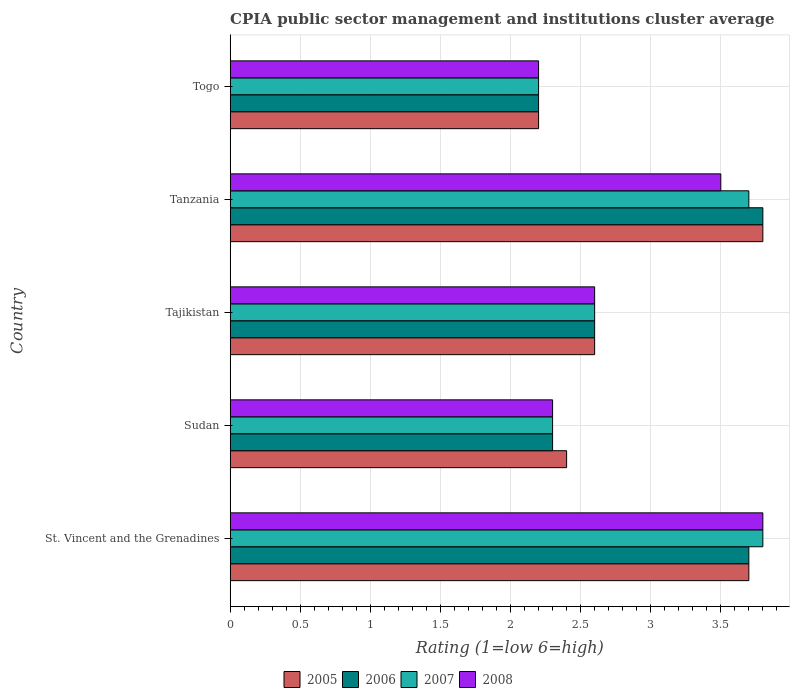How many groups of bars are there?
Offer a very short reply. 5. Are the number of bars on each tick of the Y-axis equal?
Ensure brevity in your answer.  Yes. How many bars are there on the 3rd tick from the top?
Offer a very short reply. 4. How many bars are there on the 4th tick from the bottom?
Offer a very short reply. 4. What is the label of the 2nd group of bars from the top?
Give a very brief answer. Tanzania. In how many cases, is the number of bars for a given country not equal to the number of legend labels?
Offer a very short reply. 0. Across all countries, what is the maximum CPIA rating in 2005?
Your response must be concise. 3.8. In which country was the CPIA rating in 2005 maximum?
Your answer should be very brief. Tanzania. In which country was the CPIA rating in 2008 minimum?
Ensure brevity in your answer.  Togo. What is the total CPIA rating in 2005 in the graph?
Offer a very short reply. 14.7. What is the difference between the CPIA rating in 2008 in St. Vincent and the Grenadines and that in Tanzania?
Your answer should be compact. 0.3. What is the difference between the CPIA rating in 2008 in Togo and the CPIA rating in 2006 in Tanzania?
Your answer should be very brief. -1.6. What is the average CPIA rating in 2006 per country?
Make the answer very short. 2.92. What is the difference between the CPIA rating in 2008 and CPIA rating in 2007 in St. Vincent and the Grenadines?
Your answer should be compact. 0. What is the ratio of the CPIA rating in 2008 in Sudan to that in Tajikistan?
Offer a terse response. 0.88. Is the CPIA rating in 2005 in Sudan less than that in Tajikistan?
Your response must be concise. Yes. Is the difference between the CPIA rating in 2008 in Tanzania and Togo greater than the difference between the CPIA rating in 2007 in Tanzania and Togo?
Your answer should be very brief. No. What is the difference between the highest and the second highest CPIA rating in 2006?
Your answer should be very brief. 0.1. What is the difference between the highest and the lowest CPIA rating in 2007?
Offer a terse response. 1.6. Is it the case that in every country, the sum of the CPIA rating in 2006 and CPIA rating in 2005 is greater than the sum of CPIA rating in 2007 and CPIA rating in 2008?
Your answer should be very brief. No. What does the 4th bar from the top in Sudan represents?
Your response must be concise. 2005. What does the 2nd bar from the bottom in Sudan represents?
Give a very brief answer. 2006. Is it the case that in every country, the sum of the CPIA rating in 2007 and CPIA rating in 2008 is greater than the CPIA rating in 2005?
Ensure brevity in your answer.  Yes. How many bars are there?
Ensure brevity in your answer.  20. Are all the bars in the graph horizontal?
Ensure brevity in your answer.  Yes. What is the difference between two consecutive major ticks on the X-axis?
Provide a short and direct response. 0.5. Are the values on the major ticks of X-axis written in scientific E-notation?
Keep it short and to the point. No. Does the graph contain any zero values?
Your response must be concise. No. Where does the legend appear in the graph?
Keep it short and to the point. Bottom center. How are the legend labels stacked?
Your answer should be very brief. Horizontal. What is the title of the graph?
Ensure brevity in your answer.  CPIA public sector management and institutions cluster average. What is the Rating (1=low 6=high) in 2005 in St. Vincent and the Grenadines?
Make the answer very short. 3.7. What is the Rating (1=low 6=high) in 2006 in St. Vincent and the Grenadines?
Ensure brevity in your answer.  3.7. What is the Rating (1=low 6=high) of 2008 in Sudan?
Your answer should be very brief. 2.3. What is the Rating (1=low 6=high) of 2006 in Tajikistan?
Offer a very short reply. 2.6. What is the Rating (1=low 6=high) of 2007 in Tajikistan?
Provide a succinct answer. 2.6. What is the Rating (1=low 6=high) in 2008 in Tajikistan?
Provide a succinct answer. 2.6. What is the Rating (1=low 6=high) in 2005 in Tanzania?
Give a very brief answer. 3.8. What is the Rating (1=low 6=high) of 2006 in Tanzania?
Your answer should be compact. 3.8. What is the Rating (1=low 6=high) in 2007 in Tanzania?
Your answer should be compact. 3.7. What is the Rating (1=low 6=high) of 2005 in Togo?
Make the answer very short. 2.2. What is the Rating (1=low 6=high) in 2008 in Togo?
Your answer should be compact. 2.2. Across all countries, what is the maximum Rating (1=low 6=high) in 2005?
Ensure brevity in your answer.  3.8. Across all countries, what is the maximum Rating (1=low 6=high) in 2008?
Ensure brevity in your answer.  3.8. Across all countries, what is the minimum Rating (1=low 6=high) in 2005?
Offer a very short reply. 2.2. Across all countries, what is the minimum Rating (1=low 6=high) in 2008?
Provide a short and direct response. 2.2. What is the total Rating (1=low 6=high) in 2006 in the graph?
Your answer should be compact. 14.6. What is the total Rating (1=low 6=high) of 2008 in the graph?
Keep it short and to the point. 14.4. What is the difference between the Rating (1=low 6=high) of 2006 in St. Vincent and the Grenadines and that in Sudan?
Provide a short and direct response. 1.4. What is the difference between the Rating (1=low 6=high) in 2005 in St. Vincent and the Grenadines and that in Tajikistan?
Provide a short and direct response. 1.1. What is the difference between the Rating (1=low 6=high) in 2007 in St. Vincent and the Grenadines and that in Tajikistan?
Provide a short and direct response. 1.2. What is the difference between the Rating (1=low 6=high) in 2008 in St. Vincent and the Grenadines and that in Tajikistan?
Offer a very short reply. 1.2. What is the difference between the Rating (1=low 6=high) of 2005 in St. Vincent and the Grenadines and that in Tanzania?
Your answer should be compact. -0.1. What is the difference between the Rating (1=low 6=high) of 2006 in St. Vincent and the Grenadines and that in Tanzania?
Offer a terse response. -0.1. What is the difference between the Rating (1=low 6=high) in 2007 in St. Vincent and the Grenadines and that in Tanzania?
Keep it short and to the point. 0.1. What is the difference between the Rating (1=low 6=high) in 2006 in St. Vincent and the Grenadines and that in Togo?
Ensure brevity in your answer.  1.5. What is the difference between the Rating (1=low 6=high) in 2006 in Sudan and that in Tajikistan?
Offer a very short reply. -0.3. What is the difference between the Rating (1=low 6=high) in 2007 in Sudan and that in Tajikistan?
Offer a very short reply. -0.3. What is the difference between the Rating (1=low 6=high) in 2008 in Sudan and that in Tajikistan?
Provide a short and direct response. -0.3. What is the difference between the Rating (1=low 6=high) in 2006 in Sudan and that in Tanzania?
Provide a succinct answer. -1.5. What is the difference between the Rating (1=low 6=high) in 2008 in Sudan and that in Tanzania?
Offer a very short reply. -1.2. What is the difference between the Rating (1=low 6=high) in 2006 in Sudan and that in Togo?
Ensure brevity in your answer.  0.1. What is the difference between the Rating (1=low 6=high) in 2007 in Sudan and that in Togo?
Give a very brief answer. 0.1. What is the difference between the Rating (1=low 6=high) in 2008 in Sudan and that in Togo?
Offer a very short reply. 0.1. What is the difference between the Rating (1=low 6=high) in 2008 in Tajikistan and that in Togo?
Keep it short and to the point. 0.4. What is the difference between the Rating (1=low 6=high) of 2007 in Tanzania and that in Togo?
Keep it short and to the point. 1.5. What is the difference between the Rating (1=low 6=high) of 2008 in Tanzania and that in Togo?
Offer a very short reply. 1.3. What is the difference between the Rating (1=low 6=high) of 2005 in St. Vincent and the Grenadines and the Rating (1=low 6=high) of 2007 in Sudan?
Offer a terse response. 1.4. What is the difference between the Rating (1=low 6=high) in 2005 in St. Vincent and the Grenadines and the Rating (1=low 6=high) in 2008 in Sudan?
Your answer should be very brief. 1.4. What is the difference between the Rating (1=low 6=high) in 2005 in St. Vincent and the Grenadines and the Rating (1=low 6=high) in 2006 in Tajikistan?
Keep it short and to the point. 1.1. What is the difference between the Rating (1=low 6=high) of 2006 in St. Vincent and the Grenadines and the Rating (1=low 6=high) of 2007 in Tajikistan?
Offer a terse response. 1.1. What is the difference between the Rating (1=low 6=high) of 2007 in St. Vincent and the Grenadines and the Rating (1=low 6=high) of 2008 in Tajikistan?
Offer a terse response. 1.2. What is the difference between the Rating (1=low 6=high) of 2005 in St. Vincent and the Grenadines and the Rating (1=low 6=high) of 2006 in Tanzania?
Your answer should be very brief. -0.1. What is the difference between the Rating (1=low 6=high) in 2005 in St. Vincent and the Grenadines and the Rating (1=low 6=high) in 2008 in Tanzania?
Offer a terse response. 0.2. What is the difference between the Rating (1=low 6=high) of 2006 in St. Vincent and the Grenadines and the Rating (1=low 6=high) of 2007 in Tanzania?
Your answer should be compact. 0. What is the difference between the Rating (1=low 6=high) in 2006 in St. Vincent and the Grenadines and the Rating (1=low 6=high) in 2008 in Tanzania?
Offer a terse response. 0.2. What is the difference between the Rating (1=low 6=high) in 2006 in St. Vincent and the Grenadines and the Rating (1=low 6=high) in 2008 in Togo?
Provide a short and direct response. 1.5. What is the difference between the Rating (1=low 6=high) of 2007 in St. Vincent and the Grenadines and the Rating (1=low 6=high) of 2008 in Togo?
Offer a terse response. 1.6. What is the difference between the Rating (1=low 6=high) of 2005 in Sudan and the Rating (1=low 6=high) of 2007 in Tajikistan?
Your answer should be very brief. -0.2. What is the difference between the Rating (1=low 6=high) in 2006 in Sudan and the Rating (1=low 6=high) in 2008 in Tajikistan?
Give a very brief answer. -0.3. What is the difference between the Rating (1=low 6=high) in 2007 in Sudan and the Rating (1=low 6=high) in 2008 in Tajikistan?
Provide a short and direct response. -0.3. What is the difference between the Rating (1=low 6=high) in 2006 in Sudan and the Rating (1=low 6=high) in 2007 in Tanzania?
Offer a very short reply. -1.4. What is the difference between the Rating (1=low 6=high) in 2007 in Sudan and the Rating (1=low 6=high) in 2008 in Tanzania?
Provide a succinct answer. -1.2. What is the difference between the Rating (1=low 6=high) in 2005 in Sudan and the Rating (1=low 6=high) in 2007 in Togo?
Provide a short and direct response. 0.2. What is the difference between the Rating (1=low 6=high) of 2005 in Sudan and the Rating (1=low 6=high) of 2008 in Togo?
Make the answer very short. 0.2. What is the difference between the Rating (1=low 6=high) of 2006 in Sudan and the Rating (1=low 6=high) of 2008 in Togo?
Provide a succinct answer. 0.1. What is the difference between the Rating (1=low 6=high) in 2007 in Sudan and the Rating (1=low 6=high) in 2008 in Togo?
Give a very brief answer. 0.1. What is the difference between the Rating (1=low 6=high) in 2005 in Tajikistan and the Rating (1=low 6=high) in 2007 in Tanzania?
Give a very brief answer. -1.1. What is the difference between the Rating (1=low 6=high) of 2005 in Tajikistan and the Rating (1=low 6=high) of 2006 in Togo?
Your response must be concise. 0.4. What is the difference between the Rating (1=low 6=high) of 2006 in Tajikistan and the Rating (1=low 6=high) of 2007 in Togo?
Provide a succinct answer. 0.4. What is the difference between the Rating (1=low 6=high) of 2006 in Tajikistan and the Rating (1=low 6=high) of 2008 in Togo?
Offer a terse response. 0.4. What is the difference between the Rating (1=low 6=high) of 2005 in Tanzania and the Rating (1=low 6=high) of 2007 in Togo?
Offer a terse response. 1.6. What is the difference between the Rating (1=low 6=high) in 2006 in Tanzania and the Rating (1=low 6=high) in 2007 in Togo?
Your answer should be very brief. 1.6. What is the difference between the Rating (1=low 6=high) in 2007 in Tanzania and the Rating (1=low 6=high) in 2008 in Togo?
Provide a succinct answer. 1.5. What is the average Rating (1=low 6=high) in 2005 per country?
Offer a terse response. 2.94. What is the average Rating (1=low 6=high) of 2006 per country?
Provide a short and direct response. 2.92. What is the average Rating (1=low 6=high) of 2007 per country?
Ensure brevity in your answer.  2.92. What is the average Rating (1=low 6=high) in 2008 per country?
Provide a short and direct response. 2.88. What is the difference between the Rating (1=low 6=high) of 2005 and Rating (1=low 6=high) of 2008 in St. Vincent and the Grenadines?
Ensure brevity in your answer.  -0.1. What is the difference between the Rating (1=low 6=high) in 2006 and Rating (1=low 6=high) in 2007 in St. Vincent and the Grenadines?
Keep it short and to the point. -0.1. What is the difference between the Rating (1=low 6=high) of 2006 and Rating (1=low 6=high) of 2008 in St. Vincent and the Grenadines?
Your answer should be very brief. -0.1. What is the difference between the Rating (1=low 6=high) of 2007 and Rating (1=low 6=high) of 2008 in St. Vincent and the Grenadines?
Offer a terse response. 0. What is the difference between the Rating (1=low 6=high) in 2005 and Rating (1=low 6=high) in 2006 in Sudan?
Your answer should be very brief. 0.1. What is the difference between the Rating (1=low 6=high) of 2005 and Rating (1=low 6=high) of 2008 in Sudan?
Provide a succinct answer. 0.1. What is the difference between the Rating (1=low 6=high) in 2006 and Rating (1=low 6=high) in 2007 in Sudan?
Provide a short and direct response. 0. What is the difference between the Rating (1=low 6=high) in 2006 and Rating (1=low 6=high) in 2008 in Sudan?
Give a very brief answer. 0. What is the difference between the Rating (1=low 6=high) in 2007 and Rating (1=low 6=high) in 2008 in Sudan?
Ensure brevity in your answer.  0. What is the difference between the Rating (1=low 6=high) of 2005 and Rating (1=low 6=high) of 2008 in Tajikistan?
Your answer should be very brief. 0. What is the difference between the Rating (1=low 6=high) of 2006 and Rating (1=low 6=high) of 2007 in Tajikistan?
Offer a very short reply. 0. What is the difference between the Rating (1=low 6=high) in 2006 and Rating (1=low 6=high) in 2008 in Tajikistan?
Offer a terse response. 0. What is the difference between the Rating (1=low 6=high) of 2007 and Rating (1=low 6=high) of 2008 in Tajikistan?
Your answer should be very brief. 0. What is the difference between the Rating (1=low 6=high) in 2005 and Rating (1=low 6=high) in 2007 in Tanzania?
Your answer should be compact. 0.1. What is the difference between the Rating (1=low 6=high) of 2005 and Rating (1=low 6=high) of 2008 in Tanzania?
Offer a terse response. 0.3. What is the difference between the Rating (1=low 6=high) in 2006 and Rating (1=low 6=high) in 2007 in Togo?
Ensure brevity in your answer.  0. What is the difference between the Rating (1=low 6=high) of 2007 and Rating (1=low 6=high) of 2008 in Togo?
Provide a short and direct response. 0. What is the ratio of the Rating (1=low 6=high) of 2005 in St. Vincent and the Grenadines to that in Sudan?
Provide a succinct answer. 1.54. What is the ratio of the Rating (1=low 6=high) in 2006 in St. Vincent and the Grenadines to that in Sudan?
Offer a terse response. 1.61. What is the ratio of the Rating (1=low 6=high) of 2007 in St. Vincent and the Grenadines to that in Sudan?
Offer a very short reply. 1.65. What is the ratio of the Rating (1=low 6=high) of 2008 in St. Vincent and the Grenadines to that in Sudan?
Keep it short and to the point. 1.65. What is the ratio of the Rating (1=low 6=high) of 2005 in St. Vincent and the Grenadines to that in Tajikistan?
Keep it short and to the point. 1.42. What is the ratio of the Rating (1=low 6=high) in 2006 in St. Vincent and the Grenadines to that in Tajikistan?
Make the answer very short. 1.42. What is the ratio of the Rating (1=low 6=high) in 2007 in St. Vincent and the Grenadines to that in Tajikistan?
Provide a short and direct response. 1.46. What is the ratio of the Rating (1=low 6=high) in 2008 in St. Vincent and the Grenadines to that in Tajikistan?
Give a very brief answer. 1.46. What is the ratio of the Rating (1=low 6=high) of 2005 in St. Vincent and the Grenadines to that in Tanzania?
Keep it short and to the point. 0.97. What is the ratio of the Rating (1=low 6=high) in 2006 in St. Vincent and the Grenadines to that in Tanzania?
Ensure brevity in your answer.  0.97. What is the ratio of the Rating (1=low 6=high) of 2008 in St. Vincent and the Grenadines to that in Tanzania?
Keep it short and to the point. 1.09. What is the ratio of the Rating (1=low 6=high) in 2005 in St. Vincent and the Grenadines to that in Togo?
Provide a short and direct response. 1.68. What is the ratio of the Rating (1=low 6=high) in 2006 in St. Vincent and the Grenadines to that in Togo?
Provide a succinct answer. 1.68. What is the ratio of the Rating (1=low 6=high) of 2007 in St. Vincent and the Grenadines to that in Togo?
Your response must be concise. 1.73. What is the ratio of the Rating (1=low 6=high) in 2008 in St. Vincent and the Grenadines to that in Togo?
Provide a succinct answer. 1.73. What is the ratio of the Rating (1=low 6=high) in 2006 in Sudan to that in Tajikistan?
Offer a very short reply. 0.88. What is the ratio of the Rating (1=low 6=high) of 2007 in Sudan to that in Tajikistan?
Provide a succinct answer. 0.88. What is the ratio of the Rating (1=low 6=high) of 2008 in Sudan to that in Tajikistan?
Ensure brevity in your answer.  0.88. What is the ratio of the Rating (1=low 6=high) of 2005 in Sudan to that in Tanzania?
Offer a terse response. 0.63. What is the ratio of the Rating (1=low 6=high) of 2006 in Sudan to that in Tanzania?
Your answer should be very brief. 0.61. What is the ratio of the Rating (1=low 6=high) in 2007 in Sudan to that in Tanzania?
Provide a short and direct response. 0.62. What is the ratio of the Rating (1=low 6=high) in 2008 in Sudan to that in Tanzania?
Provide a succinct answer. 0.66. What is the ratio of the Rating (1=low 6=high) in 2006 in Sudan to that in Togo?
Your answer should be very brief. 1.05. What is the ratio of the Rating (1=low 6=high) of 2007 in Sudan to that in Togo?
Provide a short and direct response. 1.05. What is the ratio of the Rating (1=low 6=high) in 2008 in Sudan to that in Togo?
Give a very brief answer. 1.05. What is the ratio of the Rating (1=low 6=high) in 2005 in Tajikistan to that in Tanzania?
Your answer should be very brief. 0.68. What is the ratio of the Rating (1=low 6=high) in 2006 in Tajikistan to that in Tanzania?
Provide a succinct answer. 0.68. What is the ratio of the Rating (1=low 6=high) in 2007 in Tajikistan to that in Tanzania?
Your answer should be very brief. 0.7. What is the ratio of the Rating (1=low 6=high) of 2008 in Tajikistan to that in Tanzania?
Provide a short and direct response. 0.74. What is the ratio of the Rating (1=low 6=high) of 2005 in Tajikistan to that in Togo?
Provide a succinct answer. 1.18. What is the ratio of the Rating (1=low 6=high) in 2006 in Tajikistan to that in Togo?
Give a very brief answer. 1.18. What is the ratio of the Rating (1=low 6=high) in 2007 in Tajikistan to that in Togo?
Offer a terse response. 1.18. What is the ratio of the Rating (1=low 6=high) in 2008 in Tajikistan to that in Togo?
Provide a succinct answer. 1.18. What is the ratio of the Rating (1=low 6=high) of 2005 in Tanzania to that in Togo?
Your answer should be very brief. 1.73. What is the ratio of the Rating (1=low 6=high) in 2006 in Tanzania to that in Togo?
Give a very brief answer. 1.73. What is the ratio of the Rating (1=low 6=high) of 2007 in Tanzania to that in Togo?
Your answer should be compact. 1.68. What is the ratio of the Rating (1=low 6=high) of 2008 in Tanzania to that in Togo?
Your answer should be compact. 1.59. What is the difference between the highest and the second highest Rating (1=low 6=high) of 2006?
Offer a terse response. 0.1. What is the difference between the highest and the lowest Rating (1=low 6=high) in 2007?
Keep it short and to the point. 1.6. What is the difference between the highest and the lowest Rating (1=low 6=high) in 2008?
Your answer should be very brief. 1.6. 